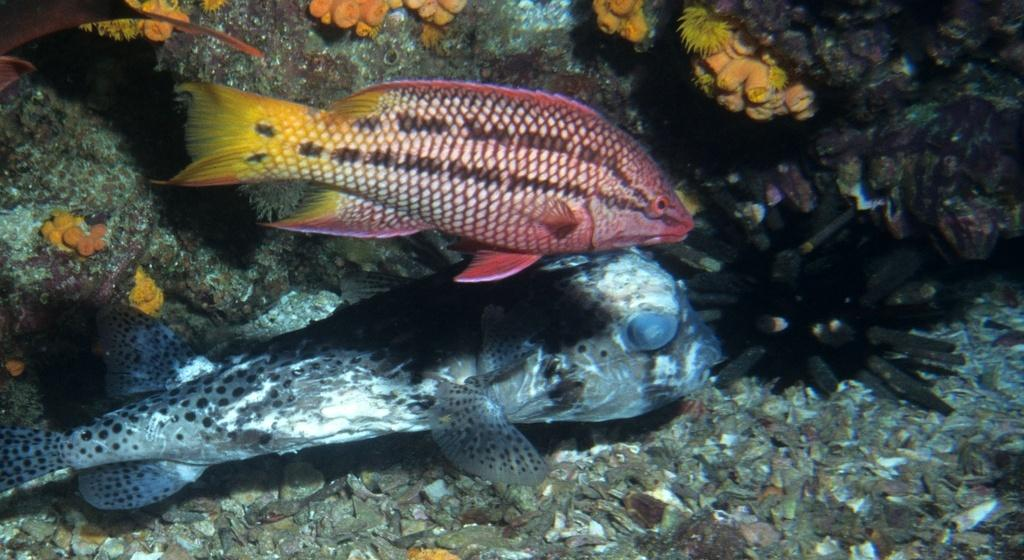How many fishes can be seen in the image? There are two fishes in the image. What else is present in the water with the fishes? There are corals in the image. Where are the fishes located? The fishes are in the water. What type of jam can be seen on the tree in the image? There is no jam or tree present in the image; it features two fishes and corals in the water. 